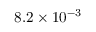Convert formula to latex. <formula><loc_0><loc_0><loc_500><loc_500>8 . 2 \times 1 0 ^ { - 3 }</formula> 